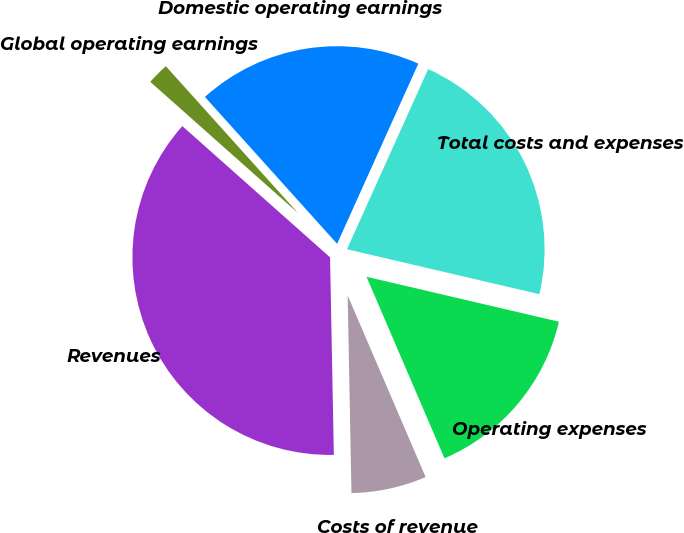Convert chart to OTSL. <chart><loc_0><loc_0><loc_500><loc_500><pie_chart><fcel>Revenues<fcel>Costs of revenue<fcel>Operating expenses<fcel>Total costs and expenses<fcel>Domestic operating earnings<fcel>Global operating earnings<nl><fcel>36.86%<fcel>6.15%<fcel>14.89%<fcel>21.91%<fcel>18.4%<fcel>1.78%<nl></chart> 